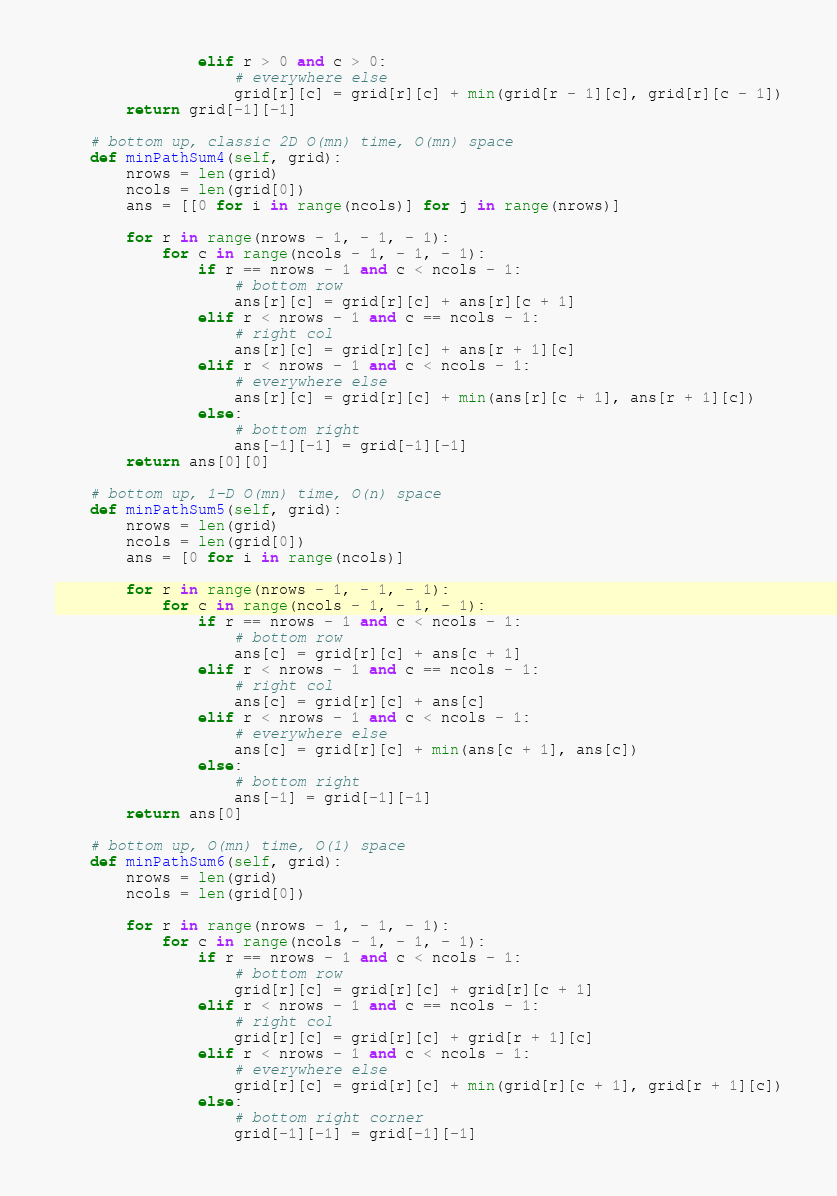<code> <loc_0><loc_0><loc_500><loc_500><_Python_>                elif r > 0 and c > 0:
                    # everywhere else
                    grid[r][c] = grid[r][c] + min(grid[r - 1][c], grid[r][c - 1])
        return grid[-1][-1]

    # bottom up, classic 2D O(mn) time, O(mn) space
    def minPathSum4(self, grid):
        nrows = len(grid)
        ncols = len(grid[0])
        ans = [[0 for i in range(ncols)] for j in range(nrows)]

        for r in range(nrows - 1, - 1, - 1):
            for c in range(ncols - 1, - 1, - 1):
                if r == nrows - 1 and c < ncols - 1:
                    # bottom row
                    ans[r][c] = grid[r][c] + ans[r][c + 1]
                elif r < nrows - 1 and c == ncols - 1:
                    # right col
                    ans[r][c] = grid[r][c] + ans[r + 1][c]
                elif r < nrows - 1 and c < ncols - 1:
                    # everywhere else
                    ans[r][c] = grid[r][c] + min(ans[r][c + 1], ans[r + 1][c])
                else:
                    # bottom right
                    ans[-1][-1] = grid[-1][-1]
        return ans[0][0]

    # bottom up, 1-D O(mn) time, O(n) space
    def minPathSum5(self, grid):
        nrows = len(grid)
        ncols = len(grid[0])
        ans = [0 for i in range(ncols)]

        for r in range(nrows - 1, - 1, - 1):
            for c in range(ncols - 1, - 1, - 1):
                if r == nrows - 1 and c < ncols - 1:
                    # bottom row
                    ans[c] = grid[r][c] + ans[c + 1]
                elif r < nrows - 1 and c == ncols - 1:
                    # right col
                    ans[c] = grid[r][c] + ans[c]
                elif r < nrows - 1 and c < ncols - 1:
                    # everywhere else
                    ans[c] = grid[r][c] + min(ans[c + 1], ans[c])
                else:
                    # bottom right
                    ans[-1] = grid[-1][-1]
        return ans[0]

    # bottom up, O(mn) time, O(1) space
    def minPathSum6(self, grid):
        nrows = len(grid)
        ncols = len(grid[0])

        for r in range(nrows - 1, - 1, - 1):
            for c in range(ncols - 1, - 1, - 1):
                if r == nrows - 1 and c < ncols - 1:
                    # bottom row
                    grid[r][c] = grid[r][c] + grid[r][c + 1]
                elif r < nrows - 1 and c == ncols - 1:
                    # right col
                    grid[r][c] = grid[r][c] + grid[r + 1][c]
                elif r < nrows - 1 and c < ncols - 1:
                    # everywhere else
                    grid[r][c] = grid[r][c] + min(grid[r][c + 1], grid[r + 1][c])
                else:
                    # bottom right corner
                    grid[-1][-1] = grid[-1][-1]</code> 